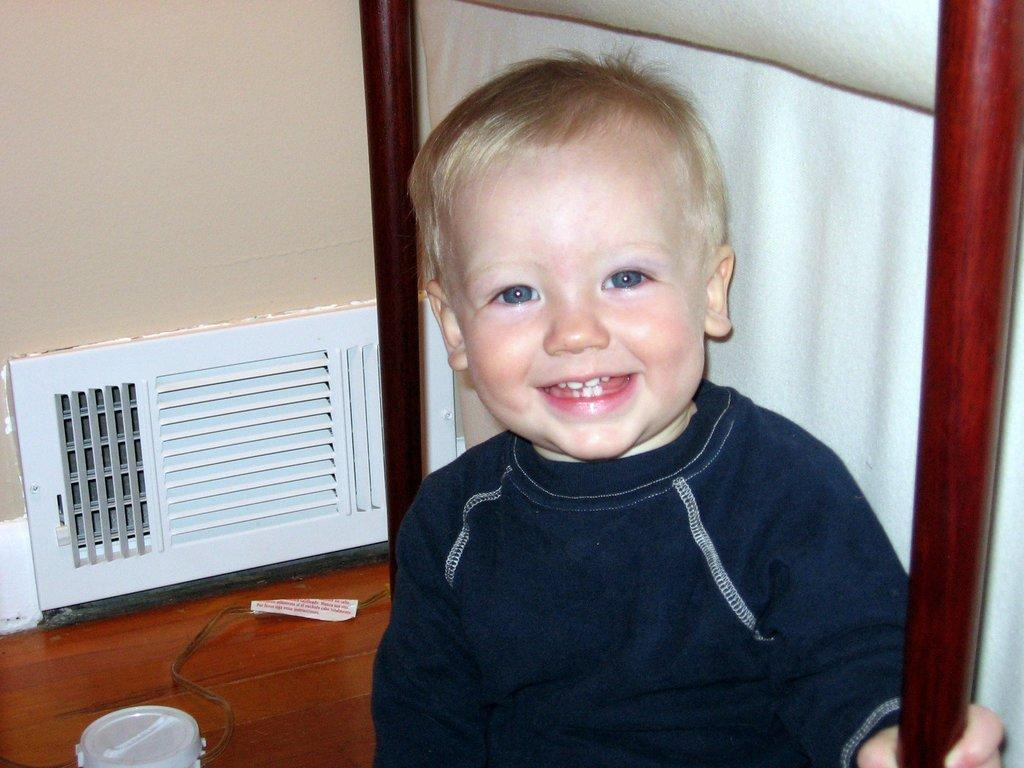What is present in the image that serves as a barrier or divider? There is a wall in the image. What object can be seen in the image that might contain a liquid? There is a bottle in the image. Who is present in the image besides the wall and the bottle? There is a child in the image. What is the child wearing in the image? The child is wearing a black color dress. How does the child fold the chain in the image? There is no chain present in the image, and therefore the child cannot fold a chain. 